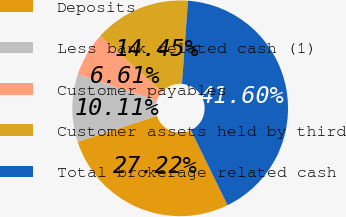Convert chart to OTSL. <chart><loc_0><loc_0><loc_500><loc_500><pie_chart><fcel>Deposits<fcel>Less bank related cash (1)<fcel>Customer payables<fcel>Customer assets held by third<fcel>Total brokerage related cash<nl><fcel>27.22%<fcel>10.11%<fcel>6.61%<fcel>14.45%<fcel>41.6%<nl></chart> 